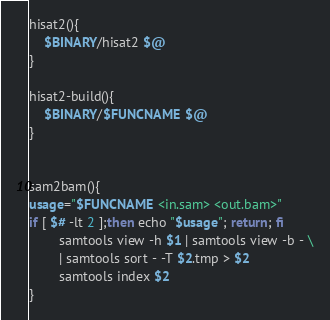<code> <loc_0><loc_0><loc_500><loc_500><_Bash_>hisat2(){
	$BINARY/hisat2 $@
}

hisat2-build(){
	$BINARY/$FUNCNAME $@
}


sam2bam(){
usage="$FUNCNAME <in.sam> <out.bam>"
if [ $# -lt 2 ];then echo "$usage"; return; fi
        samtools view -h $1 | samtools view -b - \
        | samtools sort - -T $2.tmp > $2
        samtools index $2
}


</code> 